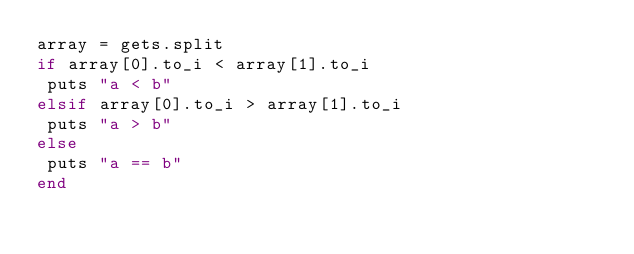<code> <loc_0><loc_0><loc_500><loc_500><_Ruby_>array = gets.split
if array[0].to_i < array[1].to_i
 puts "a < b"
elsif array[0].to_i > array[1].to_i
 puts "a > b"
else
 puts "a == b"
end</code> 